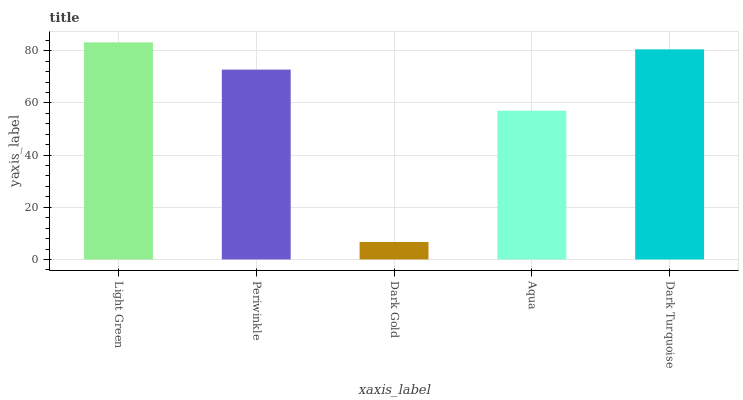Is Dark Gold the minimum?
Answer yes or no. Yes. Is Light Green the maximum?
Answer yes or no. Yes. Is Periwinkle the minimum?
Answer yes or no. No. Is Periwinkle the maximum?
Answer yes or no. No. Is Light Green greater than Periwinkle?
Answer yes or no. Yes. Is Periwinkle less than Light Green?
Answer yes or no. Yes. Is Periwinkle greater than Light Green?
Answer yes or no. No. Is Light Green less than Periwinkle?
Answer yes or no. No. Is Periwinkle the high median?
Answer yes or no. Yes. Is Periwinkle the low median?
Answer yes or no. Yes. Is Dark Gold the high median?
Answer yes or no. No. Is Light Green the low median?
Answer yes or no. No. 